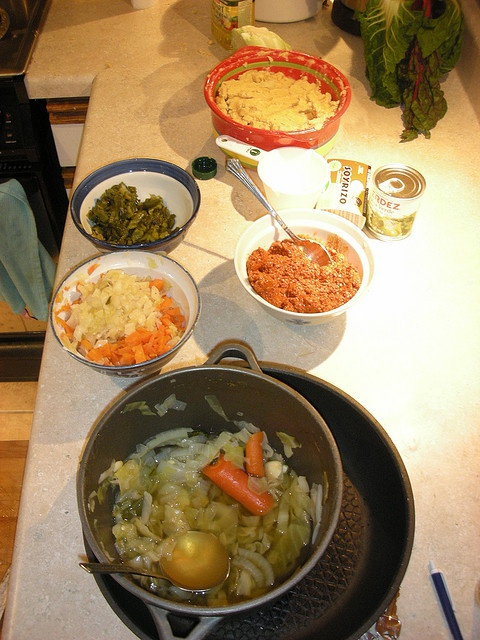Describe the objects in this image and their specific colors. I can see dining table in black, ivory, and tan tones, bowl in black and olive tones, bowl in black, tan, and red tones, bowl in black, orange, red, and gold tones, and bowl in black, beige, red, orange, and khaki tones in this image. 